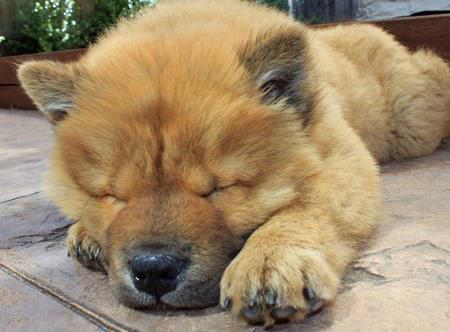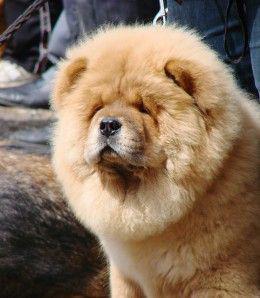The first image is the image on the left, the second image is the image on the right. Given the left and right images, does the statement "There are more living dogs in the image on the left." hold true? Answer yes or no. No. The first image is the image on the left, the second image is the image on the right. Considering the images on both sides, is "The left image contains at least two chow dogs." valid? Answer yes or no. No. 